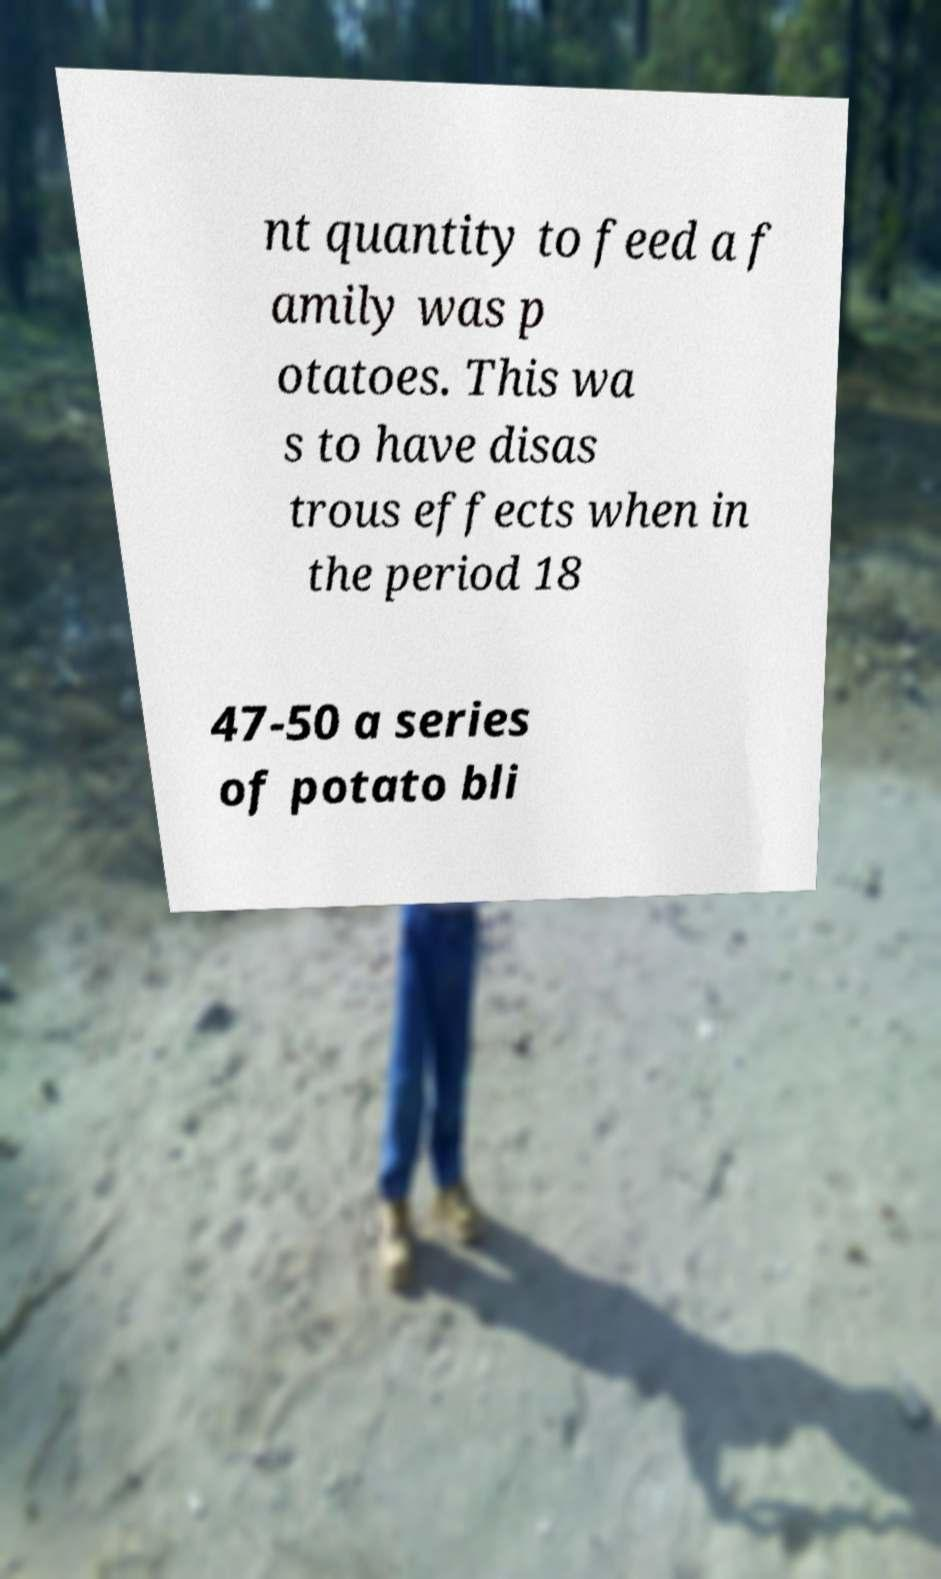Can you accurately transcribe the text from the provided image for me? nt quantity to feed a f amily was p otatoes. This wa s to have disas trous effects when in the period 18 47-50 a series of potato bli 